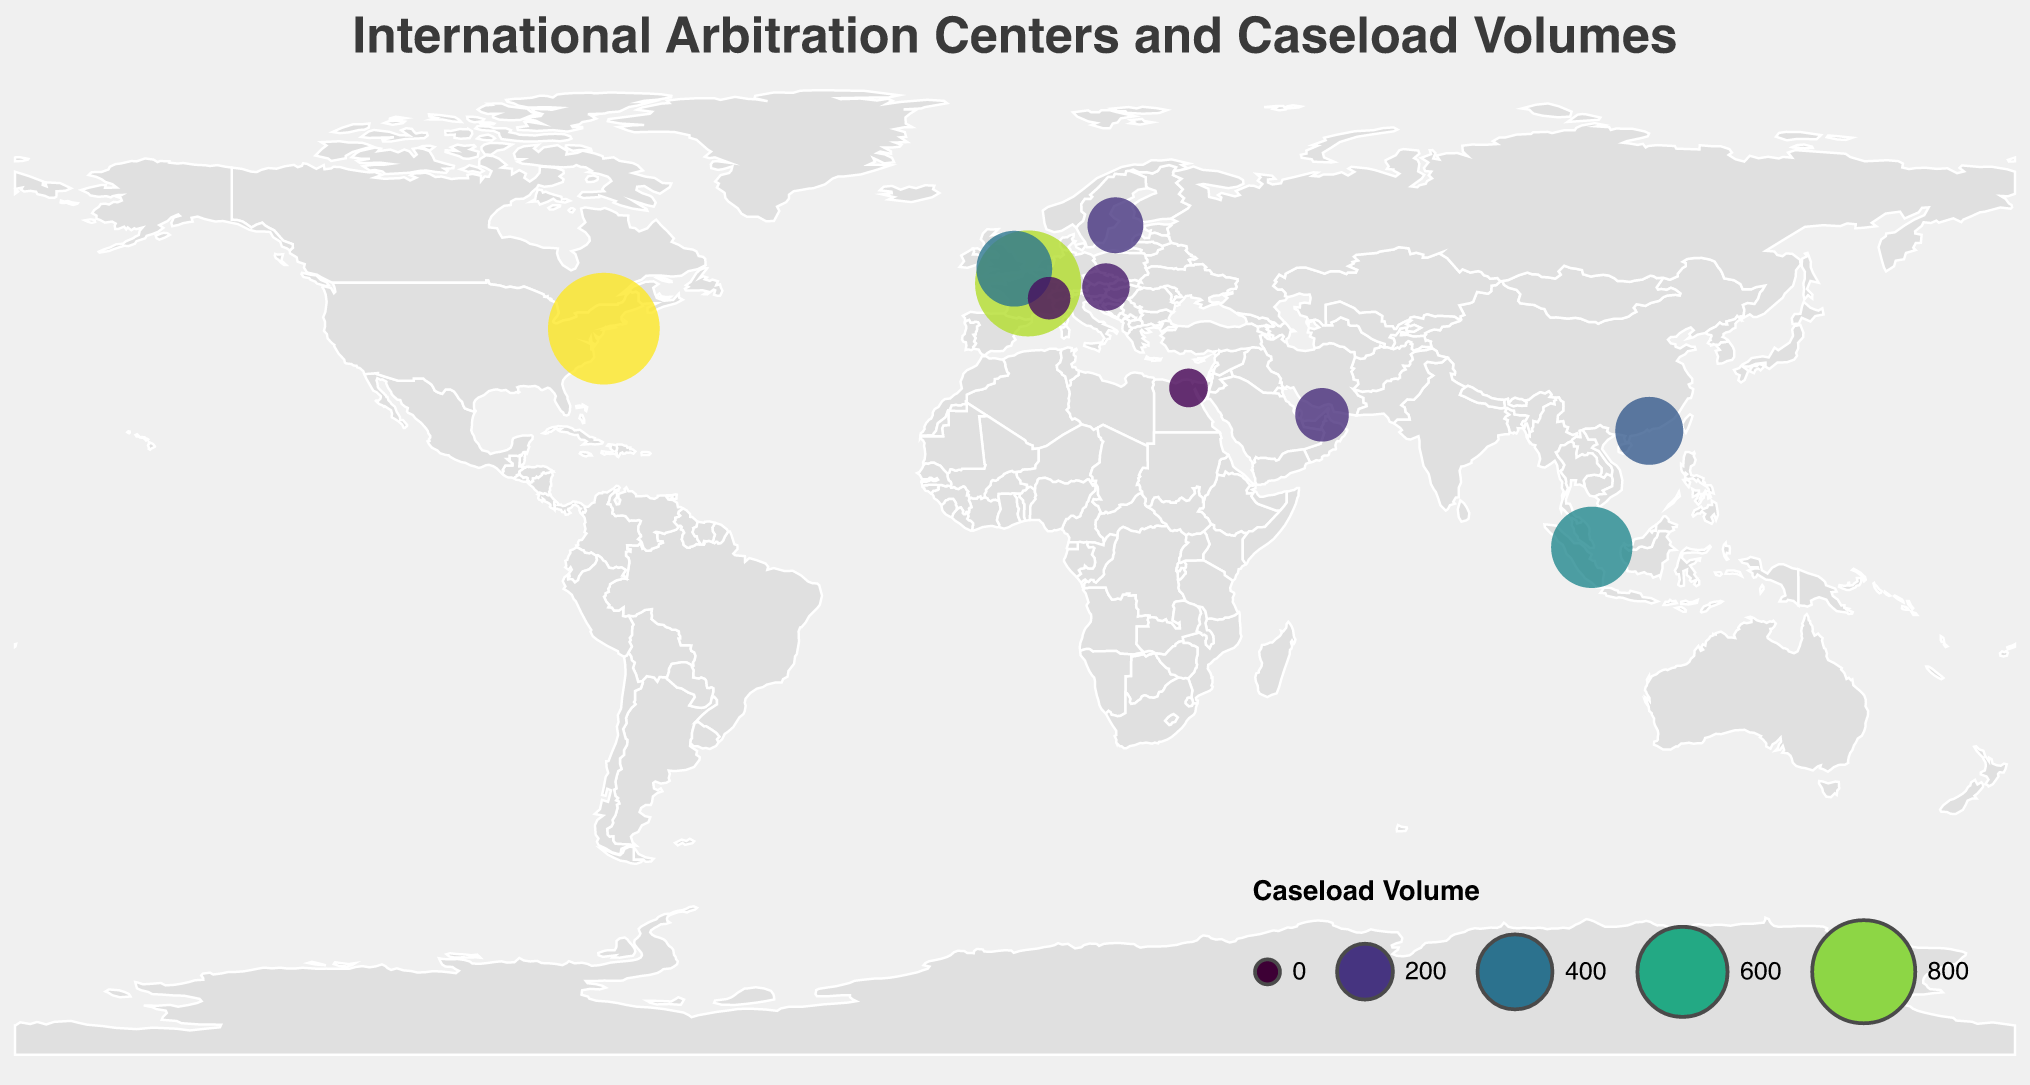How many international arbitration centers are displayed on the map? Count the number of unique arbitration centers shown on the map. There are 10 unique centers listed in the data provided.
Answer: 10 What is the title of the figure? The title of the figure is provided at the top.
Answer: International Arbitration Centers and Caseload Volumes Which arbitration center has the highest caseload volume? By looking at the sizes and colors of the circles on the map and referring to the caseload values, the American Arbitration Association (AAA) has the highest caseload volume of 950.
Answer: American Arbitration Association (AAA) What are the latitudes for SIAC and HKIAC? Refer to the coordinates for the Singapore International Arbitration Centre (SIAC) and the Hong Kong International Arbitration Centre (HKIAC) in the data. SIAC is at 1.3521 and HKIAC is at 22.3193.
Answer: 1.3521 and 22.3193 Which city hosts the International Chamber of Commerce (ICC)? Referring to the data, the International Chamber of Commerce (ICC) is located in Paris, France.
Answer: Paris What is the average caseload volume of all the centers? Sum all the caseload volumes and divide by the number of centers: (850 + 410 + 480 + 320 + 950 + 130 + 200 + 180 + 95 + 70)/10 = 3685/10 = 368.5.
Answer: 368.5 Which center has a higher caseload, LCIA or VIAC? Refer to the data provided for caseloads: LCIA has 410 and VIAC has 130. LCIA has a higher caseload.
Answer: LCIA Compare the caseload volumes of centers in Europe. Which one has the highest and which one has the lowest? The European centers listed are ICC (850), LCIA (410), VIAC (130), SCC (200), and SCAI (95). ICC has the highest caseload volume and SCAI has the lowest.
Answer: ICC and SCAI Which arbitration center is located farthest north based on latitude? Compare the latitudes of all the centers. The Stockholm Chamber of Commerce (SCC) is the highest latitude at 59.3293.
Answer: Stockholm Chamber of Commerce (SCC) Identify the centers located in Asia and their respective caseload volumes. Referring to the locations and countries, the centers in Asia are SIAC (480), HKIAC (320) and DIAC (180).
Answer: SIAC (480), HKIAC (320), and DIAC (180) 